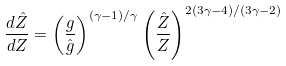Convert formula to latex. <formula><loc_0><loc_0><loc_500><loc_500>\frac { d \hat { Z } } { d Z } = \left ( \frac { g } { \hat { g } } \right ) ^ { ( \gamma - 1 ) / \gamma } \left ( \frac { \hat { Z } } { Z } \right ) ^ { 2 ( 3 \gamma - 4 ) / ( 3 \gamma - 2 ) }</formula> 